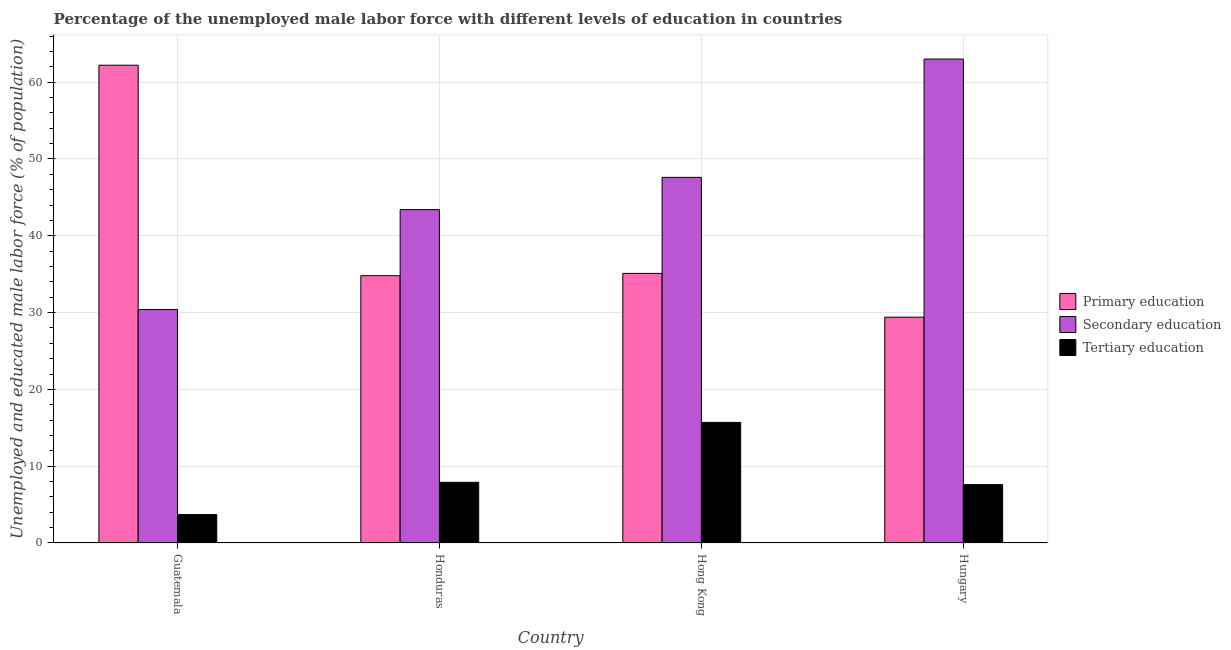How many bars are there on the 4th tick from the right?
Make the answer very short. 3. What is the label of the 4th group of bars from the left?
Keep it short and to the point. Hungary. In how many cases, is the number of bars for a given country not equal to the number of legend labels?
Provide a short and direct response. 0. What is the percentage of male labor force who received primary education in Hong Kong?
Provide a short and direct response. 35.1. Across all countries, what is the maximum percentage of male labor force who received primary education?
Your answer should be very brief. 62.2. Across all countries, what is the minimum percentage of male labor force who received primary education?
Your response must be concise. 29.4. In which country was the percentage of male labor force who received secondary education maximum?
Your answer should be very brief. Hungary. In which country was the percentage of male labor force who received primary education minimum?
Your answer should be very brief. Hungary. What is the total percentage of male labor force who received primary education in the graph?
Offer a terse response. 161.5. What is the difference between the percentage of male labor force who received tertiary education in Honduras and that in Hungary?
Provide a short and direct response. 0.3. What is the difference between the percentage of male labor force who received secondary education in Hong Kong and the percentage of male labor force who received primary education in Guatemala?
Provide a succinct answer. -14.6. What is the average percentage of male labor force who received secondary education per country?
Offer a very short reply. 46.1. What is the difference between the percentage of male labor force who received tertiary education and percentage of male labor force who received primary education in Hungary?
Provide a short and direct response. -21.8. What is the ratio of the percentage of male labor force who received secondary education in Guatemala to that in Honduras?
Provide a succinct answer. 0.7. Is the percentage of male labor force who received primary education in Guatemala less than that in Honduras?
Give a very brief answer. No. What is the difference between the highest and the second highest percentage of male labor force who received secondary education?
Provide a succinct answer. 15.4. What is the difference between the highest and the lowest percentage of male labor force who received tertiary education?
Your answer should be compact. 12. In how many countries, is the percentage of male labor force who received secondary education greater than the average percentage of male labor force who received secondary education taken over all countries?
Offer a very short reply. 2. What does the 3rd bar from the left in Guatemala represents?
Give a very brief answer. Tertiary education. What does the 2nd bar from the right in Hungary represents?
Your answer should be very brief. Secondary education. Is it the case that in every country, the sum of the percentage of male labor force who received primary education and percentage of male labor force who received secondary education is greater than the percentage of male labor force who received tertiary education?
Keep it short and to the point. Yes. Are all the bars in the graph horizontal?
Offer a very short reply. No. How many countries are there in the graph?
Your response must be concise. 4. Are the values on the major ticks of Y-axis written in scientific E-notation?
Give a very brief answer. No. How many legend labels are there?
Your answer should be very brief. 3. How are the legend labels stacked?
Make the answer very short. Vertical. What is the title of the graph?
Make the answer very short. Percentage of the unemployed male labor force with different levels of education in countries. What is the label or title of the X-axis?
Make the answer very short. Country. What is the label or title of the Y-axis?
Make the answer very short. Unemployed and educated male labor force (% of population). What is the Unemployed and educated male labor force (% of population) in Primary education in Guatemala?
Your answer should be very brief. 62.2. What is the Unemployed and educated male labor force (% of population) of Secondary education in Guatemala?
Ensure brevity in your answer.  30.4. What is the Unemployed and educated male labor force (% of population) of Tertiary education in Guatemala?
Your response must be concise. 3.7. What is the Unemployed and educated male labor force (% of population) in Primary education in Honduras?
Provide a short and direct response. 34.8. What is the Unemployed and educated male labor force (% of population) in Secondary education in Honduras?
Ensure brevity in your answer.  43.4. What is the Unemployed and educated male labor force (% of population) of Tertiary education in Honduras?
Keep it short and to the point. 7.9. What is the Unemployed and educated male labor force (% of population) of Primary education in Hong Kong?
Your response must be concise. 35.1. What is the Unemployed and educated male labor force (% of population) of Secondary education in Hong Kong?
Your answer should be compact. 47.6. What is the Unemployed and educated male labor force (% of population) in Tertiary education in Hong Kong?
Your answer should be compact. 15.7. What is the Unemployed and educated male labor force (% of population) in Primary education in Hungary?
Your response must be concise. 29.4. What is the Unemployed and educated male labor force (% of population) of Secondary education in Hungary?
Provide a succinct answer. 63. What is the Unemployed and educated male labor force (% of population) in Tertiary education in Hungary?
Make the answer very short. 7.6. Across all countries, what is the maximum Unemployed and educated male labor force (% of population) in Primary education?
Give a very brief answer. 62.2. Across all countries, what is the maximum Unemployed and educated male labor force (% of population) in Tertiary education?
Your response must be concise. 15.7. Across all countries, what is the minimum Unemployed and educated male labor force (% of population) of Primary education?
Provide a succinct answer. 29.4. Across all countries, what is the minimum Unemployed and educated male labor force (% of population) of Secondary education?
Keep it short and to the point. 30.4. Across all countries, what is the minimum Unemployed and educated male labor force (% of population) of Tertiary education?
Keep it short and to the point. 3.7. What is the total Unemployed and educated male labor force (% of population) in Primary education in the graph?
Your answer should be very brief. 161.5. What is the total Unemployed and educated male labor force (% of population) of Secondary education in the graph?
Your answer should be very brief. 184.4. What is the total Unemployed and educated male labor force (% of population) in Tertiary education in the graph?
Your response must be concise. 34.9. What is the difference between the Unemployed and educated male labor force (% of population) in Primary education in Guatemala and that in Honduras?
Offer a terse response. 27.4. What is the difference between the Unemployed and educated male labor force (% of population) in Secondary education in Guatemala and that in Honduras?
Provide a succinct answer. -13. What is the difference between the Unemployed and educated male labor force (% of population) of Primary education in Guatemala and that in Hong Kong?
Your answer should be compact. 27.1. What is the difference between the Unemployed and educated male labor force (% of population) in Secondary education in Guatemala and that in Hong Kong?
Ensure brevity in your answer.  -17.2. What is the difference between the Unemployed and educated male labor force (% of population) of Primary education in Guatemala and that in Hungary?
Offer a very short reply. 32.8. What is the difference between the Unemployed and educated male labor force (% of population) of Secondary education in Guatemala and that in Hungary?
Your answer should be very brief. -32.6. What is the difference between the Unemployed and educated male labor force (% of population) of Primary education in Honduras and that in Hungary?
Your answer should be compact. 5.4. What is the difference between the Unemployed and educated male labor force (% of population) of Secondary education in Honduras and that in Hungary?
Your response must be concise. -19.6. What is the difference between the Unemployed and educated male labor force (% of population) in Tertiary education in Honduras and that in Hungary?
Provide a succinct answer. 0.3. What is the difference between the Unemployed and educated male labor force (% of population) of Primary education in Hong Kong and that in Hungary?
Ensure brevity in your answer.  5.7. What is the difference between the Unemployed and educated male labor force (% of population) in Secondary education in Hong Kong and that in Hungary?
Your answer should be very brief. -15.4. What is the difference between the Unemployed and educated male labor force (% of population) in Primary education in Guatemala and the Unemployed and educated male labor force (% of population) in Secondary education in Honduras?
Provide a short and direct response. 18.8. What is the difference between the Unemployed and educated male labor force (% of population) in Primary education in Guatemala and the Unemployed and educated male labor force (% of population) in Tertiary education in Honduras?
Ensure brevity in your answer.  54.3. What is the difference between the Unemployed and educated male labor force (% of population) of Secondary education in Guatemala and the Unemployed and educated male labor force (% of population) of Tertiary education in Honduras?
Provide a short and direct response. 22.5. What is the difference between the Unemployed and educated male labor force (% of population) in Primary education in Guatemala and the Unemployed and educated male labor force (% of population) in Tertiary education in Hong Kong?
Keep it short and to the point. 46.5. What is the difference between the Unemployed and educated male labor force (% of population) of Secondary education in Guatemala and the Unemployed and educated male labor force (% of population) of Tertiary education in Hong Kong?
Give a very brief answer. 14.7. What is the difference between the Unemployed and educated male labor force (% of population) in Primary education in Guatemala and the Unemployed and educated male labor force (% of population) in Secondary education in Hungary?
Give a very brief answer. -0.8. What is the difference between the Unemployed and educated male labor force (% of population) of Primary education in Guatemala and the Unemployed and educated male labor force (% of population) of Tertiary education in Hungary?
Provide a short and direct response. 54.6. What is the difference between the Unemployed and educated male labor force (% of population) of Secondary education in Guatemala and the Unemployed and educated male labor force (% of population) of Tertiary education in Hungary?
Offer a very short reply. 22.8. What is the difference between the Unemployed and educated male labor force (% of population) in Primary education in Honduras and the Unemployed and educated male labor force (% of population) in Secondary education in Hong Kong?
Make the answer very short. -12.8. What is the difference between the Unemployed and educated male labor force (% of population) of Primary education in Honduras and the Unemployed and educated male labor force (% of population) of Tertiary education in Hong Kong?
Ensure brevity in your answer.  19.1. What is the difference between the Unemployed and educated male labor force (% of population) in Secondary education in Honduras and the Unemployed and educated male labor force (% of population) in Tertiary education in Hong Kong?
Your answer should be very brief. 27.7. What is the difference between the Unemployed and educated male labor force (% of population) of Primary education in Honduras and the Unemployed and educated male labor force (% of population) of Secondary education in Hungary?
Provide a short and direct response. -28.2. What is the difference between the Unemployed and educated male labor force (% of population) of Primary education in Honduras and the Unemployed and educated male labor force (% of population) of Tertiary education in Hungary?
Your answer should be very brief. 27.2. What is the difference between the Unemployed and educated male labor force (% of population) in Secondary education in Honduras and the Unemployed and educated male labor force (% of population) in Tertiary education in Hungary?
Keep it short and to the point. 35.8. What is the difference between the Unemployed and educated male labor force (% of population) in Primary education in Hong Kong and the Unemployed and educated male labor force (% of population) in Secondary education in Hungary?
Your response must be concise. -27.9. What is the average Unemployed and educated male labor force (% of population) of Primary education per country?
Provide a succinct answer. 40.38. What is the average Unemployed and educated male labor force (% of population) in Secondary education per country?
Keep it short and to the point. 46.1. What is the average Unemployed and educated male labor force (% of population) of Tertiary education per country?
Keep it short and to the point. 8.72. What is the difference between the Unemployed and educated male labor force (% of population) in Primary education and Unemployed and educated male labor force (% of population) in Secondary education in Guatemala?
Provide a short and direct response. 31.8. What is the difference between the Unemployed and educated male labor force (% of population) in Primary education and Unemployed and educated male labor force (% of population) in Tertiary education in Guatemala?
Provide a succinct answer. 58.5. What is the difference between the Unemployed and educated male labor force (% of population) in Secondary education and Unemployed and educated male labor force (% of population) in Tertiary education in Guatemala?
Your answer should be very brief. 26.7. What is the difference between the Unemployed and educated male labor force (% of population) in Primary education and Unemployed and educated male labor force (% of population) in Tertiary education in Honduras?
Give a very brief answer. 26.9. What is the difference between the Unemployed and educated male labor force (% of population) of Secondary education and Unemployed and educated male labor force (% of population) of Tertiary education in Honduras?
Offer a very short reply. 35.5. What is the difference between the Unemployed and educated male labor force (% of population) of Primary education and Unemployed and educated male labor force (% of population) of Tertiary education in Hong Kong?
Keep it short and to the point. 19.4. What is the difference between the Unemployed and educated male labor force (% of population) in Secondary education and Unemployed and educated male labor force (% of population) in Tertiary education in Hong Kong?
Provide a short and direct response. 31.9. What is the difference between the Unemployed and educated male labor force (% of population) of Primary education and Unemployed and educated male labor force (% of population) of Secondary education in Hungary?
Keep it short and to the point. -33.6. What is the difference between the Unemployed and educated male labor force (% of population) in Primary education and Unemployed and educated male labor force (% of population) in Tertiary education in Hungary?
Your response must be concise. 21.8. What is the difference between the Unemployed and educated male labor force (% of population) of Secondary education and Unemployed and educated male labor force (% of population) of Tertiary education in Hungary?
Keep it short and to the point. 55.4. What is the ratio of the Unemployed and educated male labor force (% of population) of Primary education in Guatemala to that in Honduras?
Your answer should be very brief. 1.79. What is the ratio of the Unemployed and educated male labor force (% of population) in Secondary education in Guatemala to that in Honduras?
Offer a very short reply. 0.7. What is the ratio of the Unemployed and educated male labor force (% of population) of Tertiary education in Guatemala to that in Honduras?
Ensure brevity in your answer.  0.47. What is the ratio of the Unemployed and educated male labor force (% of population) of Primary education in Guatemala to that in Hong Kong?
Your answer should be very brief. 1.77. What is the ratio of the Unemployed and educated male labor force (% of population) in Secondary education in Guatemala to that in Hong Kong?
Offer a very short reply. 0.64. What is the ratio of the Unemployed and educated male labor force (% of population) in Tertiary education in Guatemala to that in Hong Kong?
Your response must be concise. 0.24. What is the ratio of the Unemployed and educated male labor force (% of population) in Primary education in Guatemala to that in Hungary?
Your response must be concise. 2.12. What is the ratio of the Unemployed and educated male labor force (% of population) in Secondary education in Guatemala to that in Hungary?
Offer a very short reply. 0.48. What is the ratio of the Unemployed and educated male labor force (% of population) of Tertiary education in Guatemala to that in Hungary?
Make the answer very short. 0.49. What is the ratio of the Unemployed and educated male labor force (% of population) in Secondary education in Honduras to that in Hong Kong?
Your answer should be compact. 0.91. What is the ratio of the Unemployed and educated male labor force (% of population) of Tertiary education in Honduras to that in Hong Kong?
Your answer should be very brief. 0.5. What is the ratio of the Unemployed and educated male labor force (% of population) in Primary education in Honduras to that in Hungary?
Your answer should be very brief. 1.18. What is the ratio of the Unemployed and educated male labor force (% of population) in Secondary education in Honduras to that in Hungary?
Keep it short and to the point. 0.69. What is the ratio of the Unemployed and educated male labor force (% of population) in Tertiary education in Honduras to that in Hungary?
Your response must be concise. 1.04. What is the ratio of the Unemployed and educated male labor force (% of population) in Primary education in Hong Kong to that in Hungary?
Offer a very short reply. 1.19. What is the ratio of the Unemployed and educated male labor force (% of population) in Secondary education in Hong Kong to that in Hungary?
Provide a succinct answer. 0.76. What is the ratio of the Unemployed and educated male labor force (% of population) in Tertiary education in Hong Kong to that in Hungary?
Offer a terse response. 2.07. What is the difference between the highest and the second highest Unemployed and educated male labor force (% of population) of Primary education?
Provide a succinct answer. 27.1. What is the difference between the highest and the second highest Unemployed and educated male labor force (% of population) of Secondary education?
Provide a short and direct response. 15.4. What is the difference between the highest and the lowest Unemployed and educated male labor force (% of population) in Primary education?
Provide a short and direct response. 32.8. What is the difference between the highest and the lowest Unemployed and educated male labor force (% of population) in Secondary education?
Make the answer very short. 32.6. 